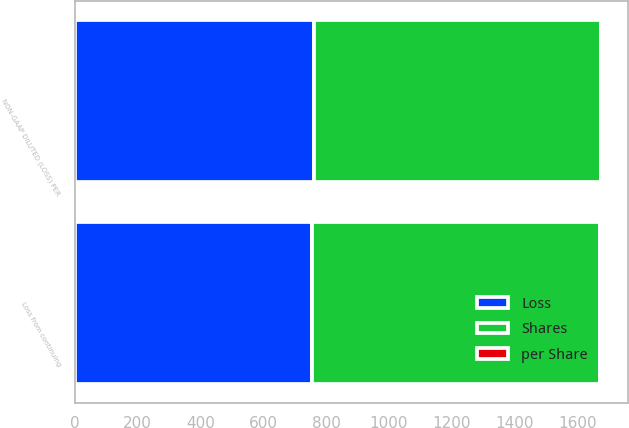Convert chart to OTSL. <chart><loc_0><loc_0><loc_500><loc_500><stacked_bar_chart><ecel><fcel>Loss from continuing<fcel>NON-GAAP DILUTED (LOSS) PER<nl><fcel>Shares<fcel>915<fcel>915<nl><fcel>Loss<fcel>755<fcel>760<nl><fcel>per Share<fcel>1.21<fcel>1.2<nl></chart> 